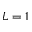Convert formula to latex. <formula><loc_0><loc_0><loc_500><loc_500>L = 1</formula> 